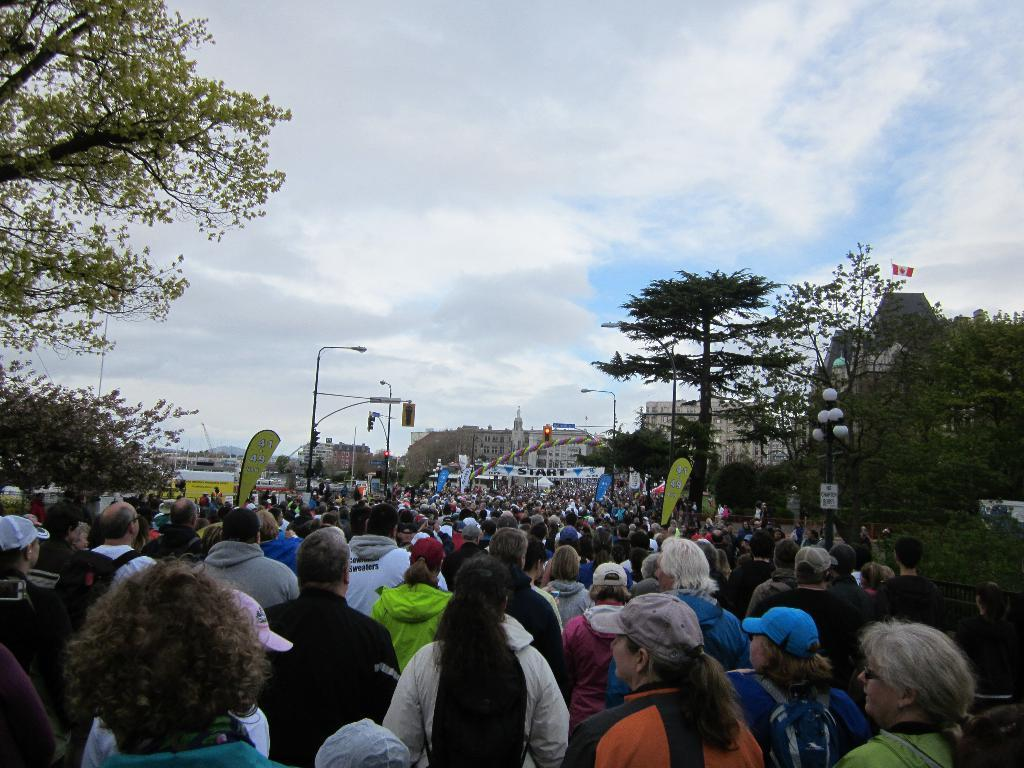How many people are in the group visible in the image? There is a group of people in the image, but the exact number cannot be determined from the provided facts. What type of natural vegetation can be seen in the image? There are trees in the image. What are the lights on poles used for in the image? The lights on poles are likely used for illumination in the image. What type of structures can be seen in the background of the image? There are buildings in the background of the image. What is visible in the sky in the image? The sky is visible in the background of the image, and clouds are present. What type of jewel is being balanced on the head of the person in the image? There is no jewel or person balancing anything present in the image. 